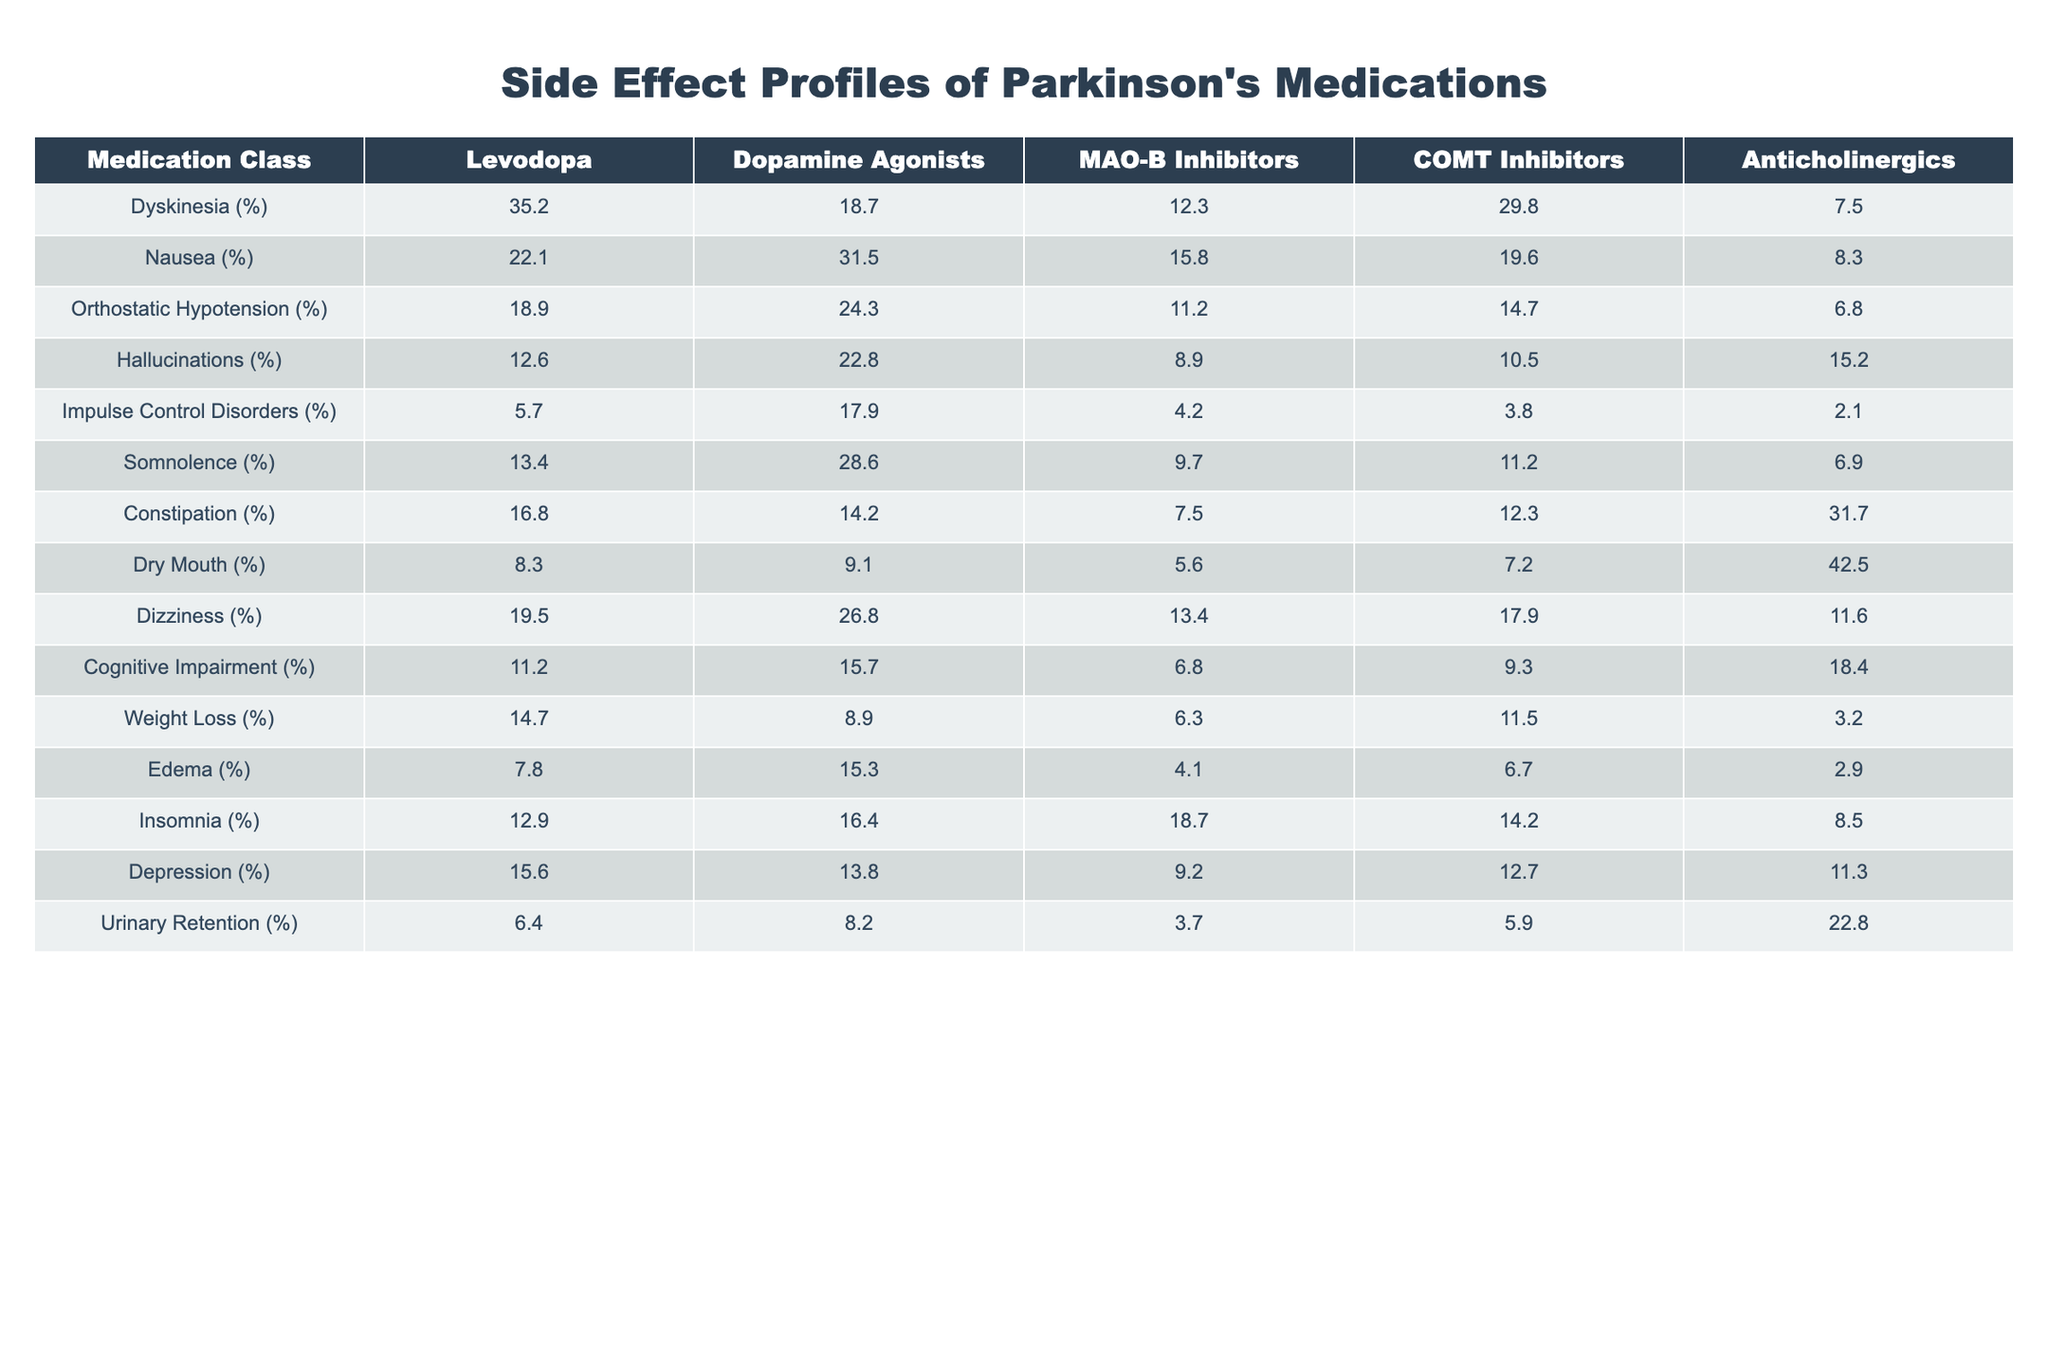What percentage of patients experience dyskinesia when treated with Levodopa? The table shows that the percentage of patients experiencing dyskinesia with Levodopa is 35.2%.
Answer: 35.2% Which medication class has the highest incidence of nausea? According to the table, dopamine agonists have the highest percentage of nausea at 31.5%.
Answer: 31.5% What is the difference in the percentage of patients reporting hallucinations between dopamine agonists and anticholinergics? The percentage for dopamine agonists is 22.8%, while for anticholinergics it's 15.2%. The difference is 22.8% - 15.2% = 7.6%.
Answer: 7.6% Is the incidence of impulse control disorders higher in dopamine agonists than in MAO-B inhibitors? Yes, the percentage for dopamine agonists is 17.9%, while for MAO-B inhibitors it is only 4.2%, indicating a higher incidence in dopamine agonists.
Answer: Yes What medication class shows the lowest percentage of urinary retention? The table indicates that COMT inhibitors have the lowest percentage of urinary retention at 5.9%.
Answer: 5.9% What is the average percentage of somnolence across all medication classes? To find the average, we sum the percentages of somnolence: (13.4 + 28.6 + 9.7 + 11.2 + 6.9) = 69.8%. Then we divide by the number of medication classes (5): 69.8 / 5 = 13.96%.
Answer: 13.96% Which side effect is most commonly reported with anticholinergics? The table shows that dry mouth is the most common side effect reported with anticholinergics at 42.5%.
Answer: 42.5% Is the incidence of dizziness higher in COMT inhibitors compared to MAO-B inhibitors? Yes, the table shows that dizziness in COMT inhibitors is 17.9%, while in MAO-B inhibitors it is 13.4%, so it is indeed higher in COMT inhibitors.
Answer: Yes What is the total percentage of patients experiencing orthostatic hypotension across all medication classes? The total percentage is found by summing the percentages: 18.9 + 24.3 + 11.2 + 14.7 + 6.8 = 75.9%.
Answer: 75.9% Which medication class has the highest percentage of cognitive impairment? According to the table, the medication class with the highest percentage of cognitive impairment is anticholinergics at 18.4%.
Answer: 18.4% 